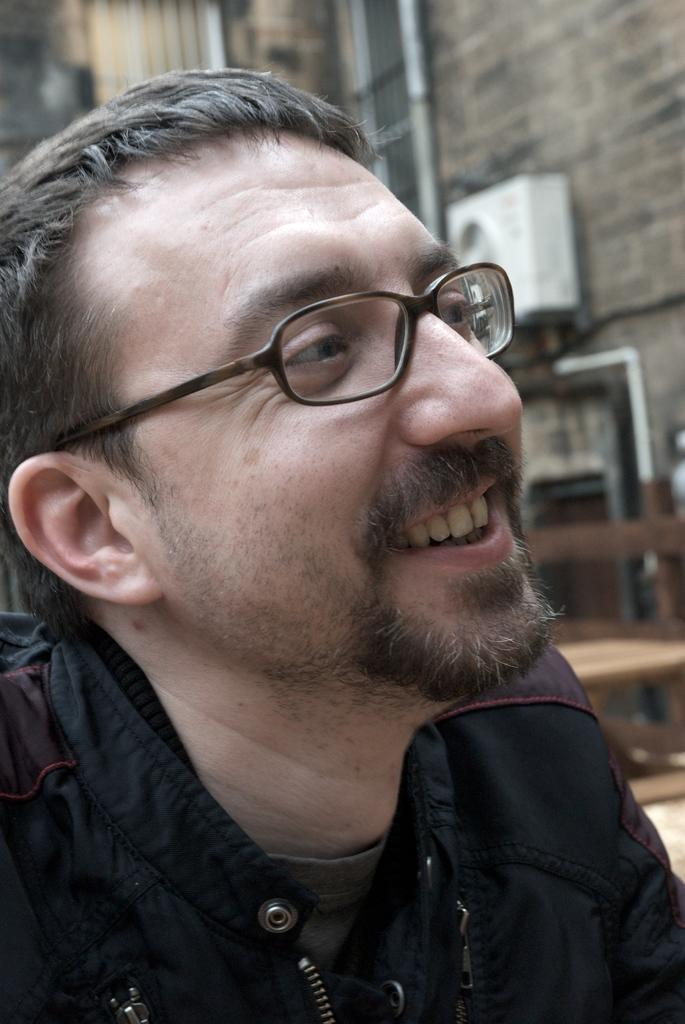What is the main subject of the image? There is a person in the image. What is the person wearing? The person is wearing a black dress and spectacles. What is the person's facial expression? The person is smiling. What can be seen in the background of the image? There is a building, pipes, and a white-colored object in the background of the image. What time of day is it in the image, and what type of horse can be seen in the background? The time of day is not mentioned in the image, and there is no horse present in the background. What type of wax is being used by the person in the image? There is no indication of wax usage in the image. 